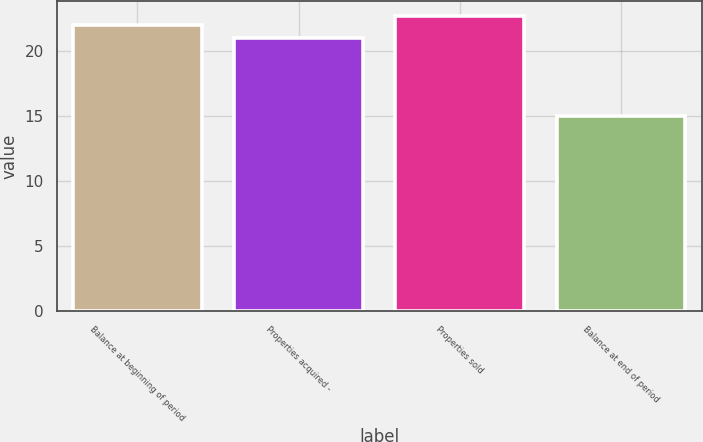<chart> <loc_0><loc_0><loc_500><loc_500><bar_chart><fcel>Balance at beginning of period<fcel>Properties acquired -<fcel>Properties sold<fcel>Balance at end of period<nl><fcel>22<fcel>21<fcel>22.7<fcel>15<nl></chart> 